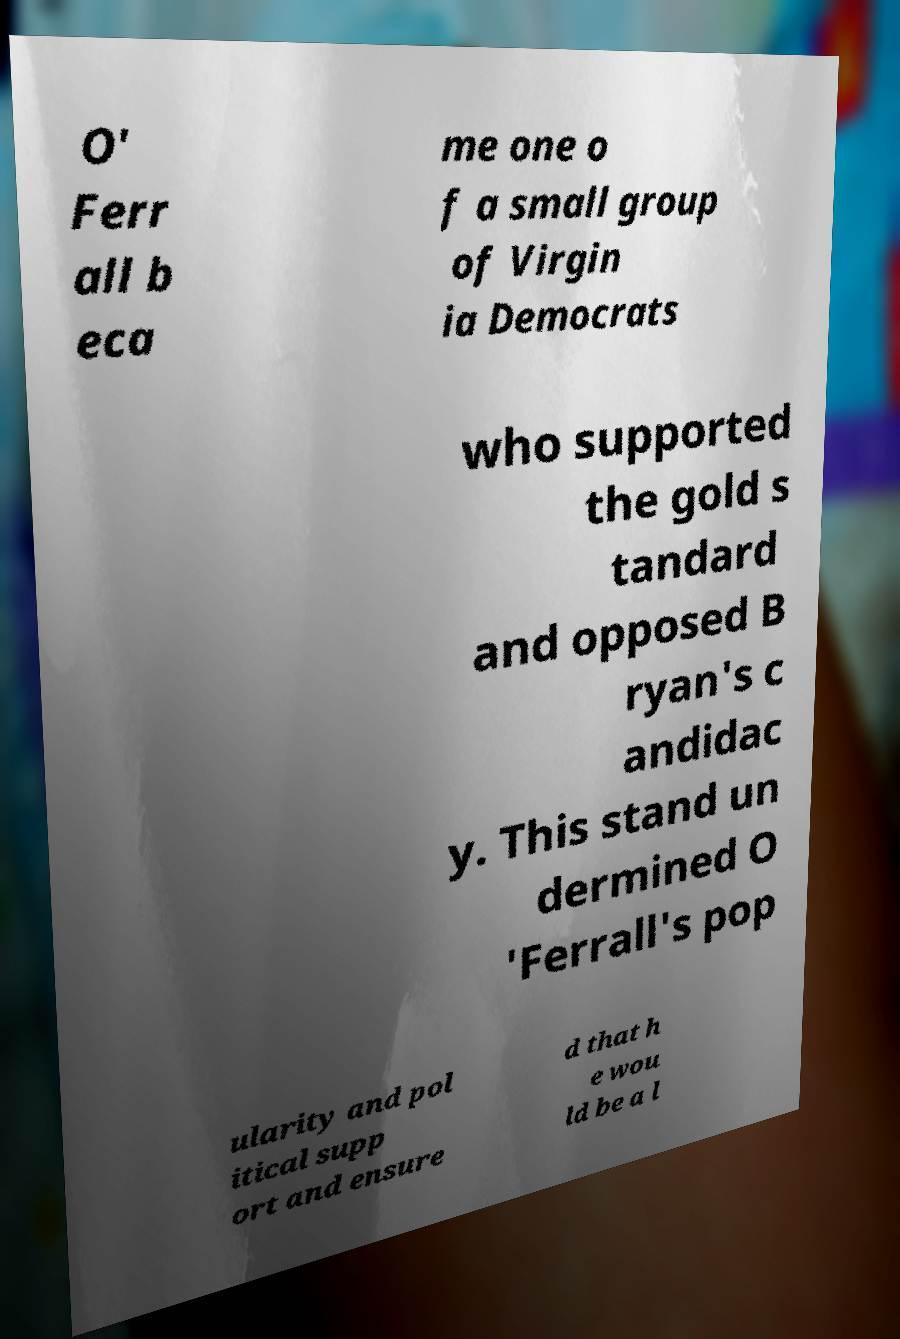Could you extract and type out the text from this image? O' Ferr all b eca me one o f a small group of Virgin ia Democrats who supported the gold s tandard and opposed B ryan's c andidac y. This stand un dermined O 'Ferrall's pop ularity and pol itical supp ort and ensure d that h e wou ld be a l 